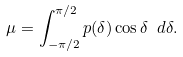Convert formula to latex. <formula><loc_0><loc_0><loc_500><loc_500>\mu = \int _ { - \pi / 2 } ^ { \pi / 2 } p ( \delta ) \cos \delta \ d \delta .</formula> 